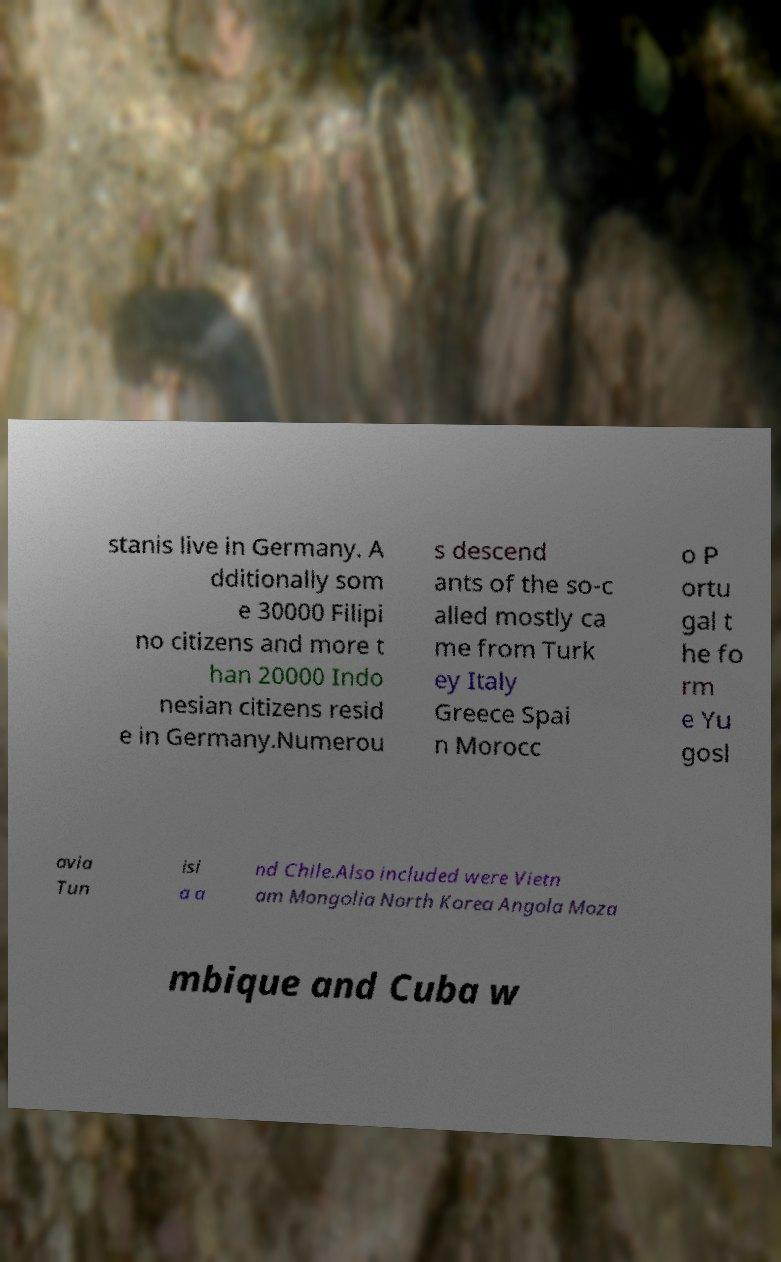Please read and relay the text visible in this image. What does it say? stanis live in Germany. A dditionally som e 30000 Filipi no citizens and more t han 20000 Indo nesian citizens resid e in Germany.Numerou s descend ants of the so-c alled mostly ca me from Turk ey Italy Greece Spai n Morocc o P ortu gal t he fo rm e Yu gosl avia Tun isi a a nd Chile.Also included were Vietn am Mongolia North Korea Angola Moza mbique and Cuba w 